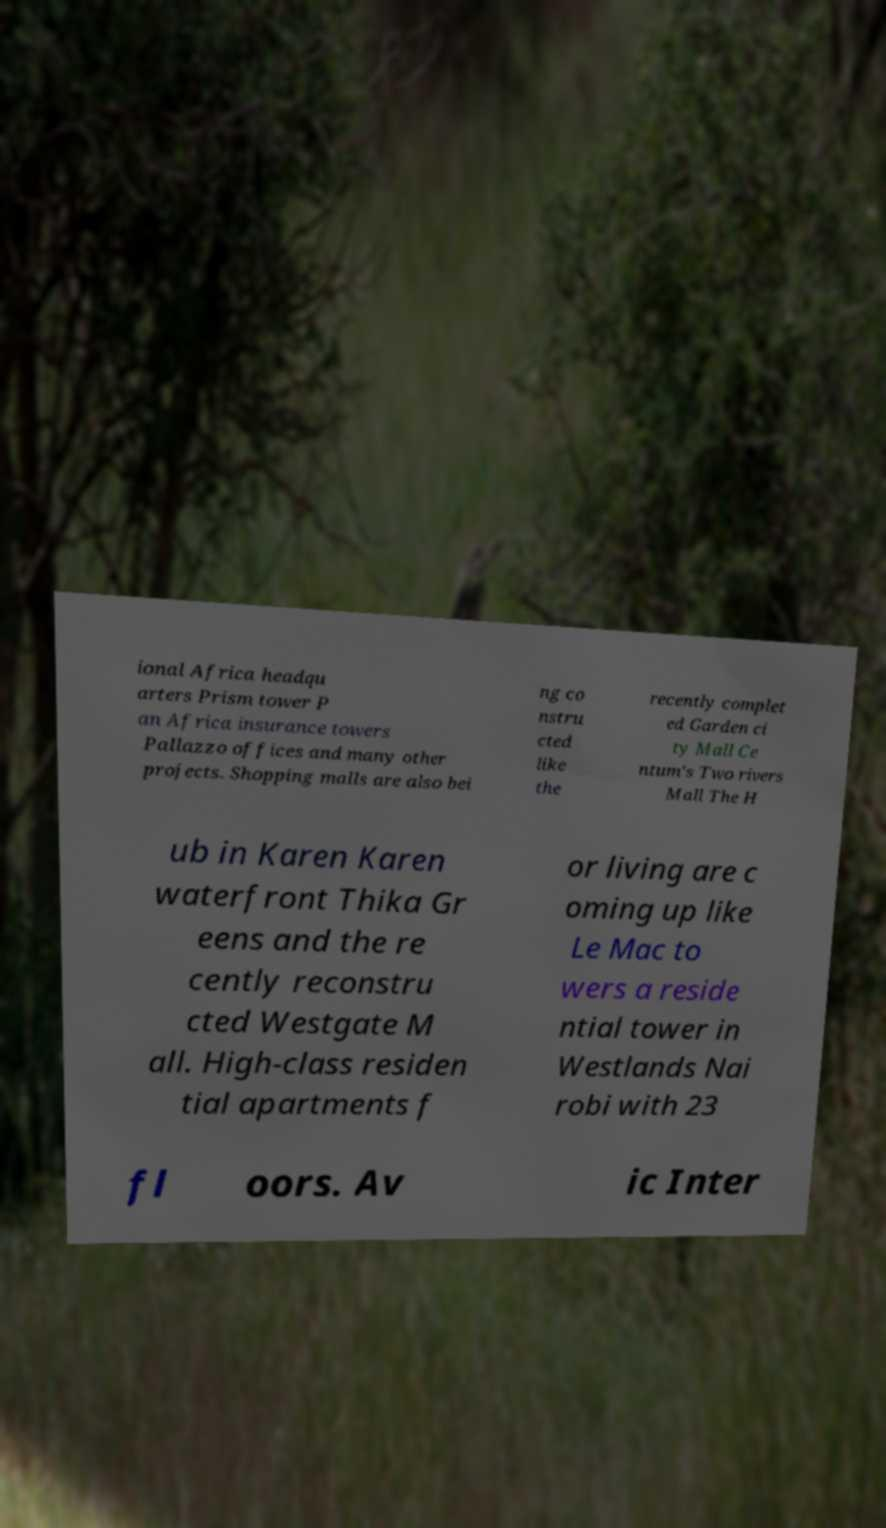There's text embedded in this image that I need extracted. Can you transcribe it verbatim? ional Africa headqu arters Prism tower P an Africa insurance towers Pallazzo offices and many other projects. Shopping malls are also bei ng co nstru cted like the recently complet ed Garden ci ty Mall Ce ntum's Two rivers Mall The H ub in Karen Karen waterfront Thika Gr eens and the re cently reconstru cted Westgate M all. High-class residen tial apartments f or living are c oming up like Le Mac to wers a reside ntial tower in Westlands Nai robi with 23 fl oors. Av ic Inter 